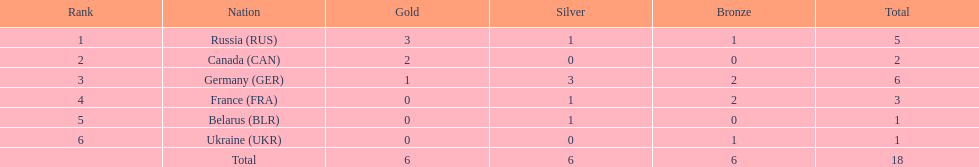Which nation solely secured gold medals in the biathlon event during the 1994 winter olympics? Canada (CAN). 